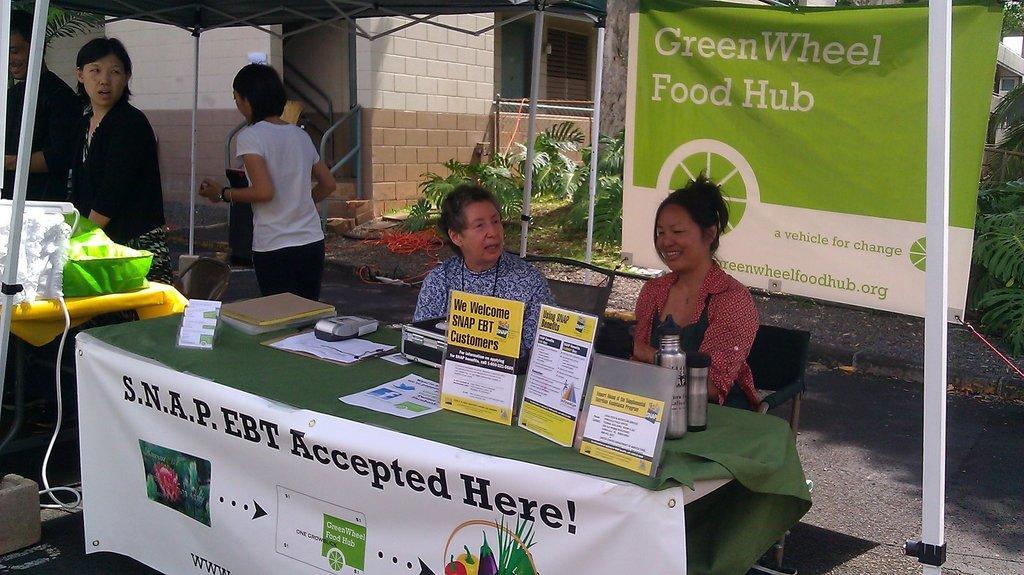In one or two sentences, can you explain what this image depicts? In this picture there are two people sitting on the chairs behind the table. There are boards, books, bottles and there is a box, device and there are papers on the table and there is a banner on the table, there is text and there are pictures of vegetables on the banner. On the left side of the image there is a person walking and there are two people standing under the tent and there are objects on the table. At the back there is a building and there is a fence and there are trees and there is a banner. At the bottom there is a road and there is an object. 